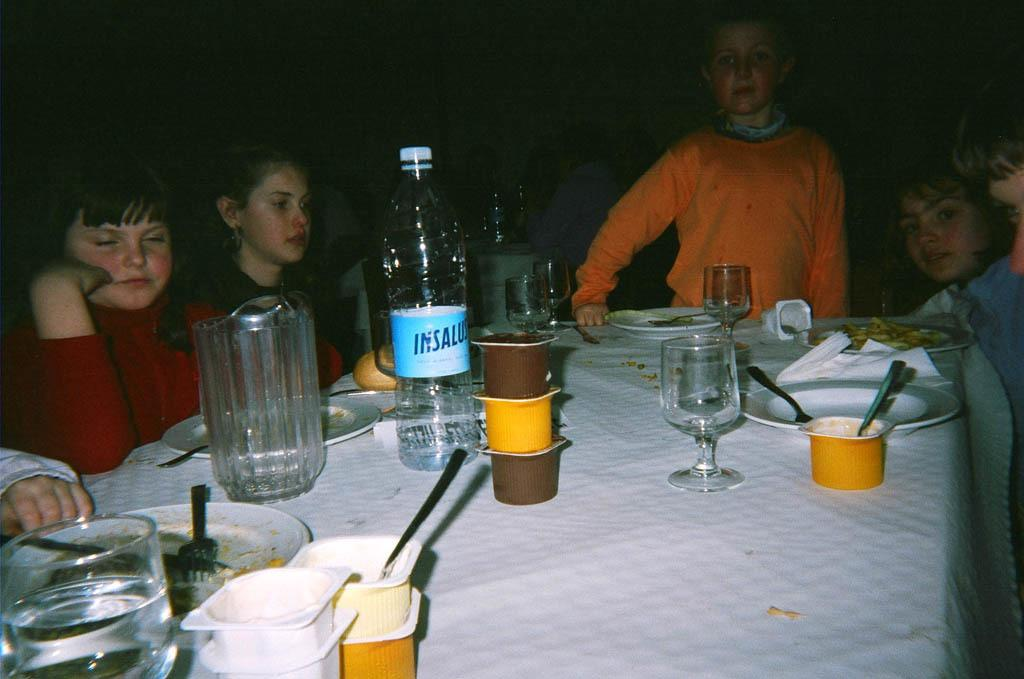What are the people in the image doing? The people in the image are sitting on chairs. Is there anyone standing in the image? Yes, there is a person standing in the image. What is in front of the people? There is a table in front of the people. What items can be seen on the table? There is a bottle, a glass, a plate, a fork, a spoon, and cups on the table. What type of cook is the person standing in the image? There is no indication in the image that the person standing is a cook, so it cannot be determined from the picture. 